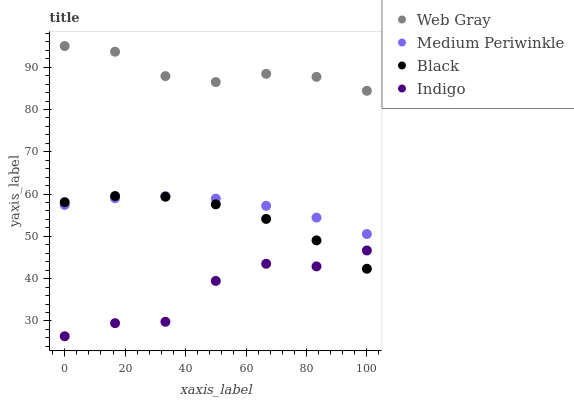Does Indigo have the minimum area under the curve?
Answer yes or no. Yes. Does Web Gray have the maximum area under the curve?
Answer yes or no. Yes. Does Medium Periwinkle have the minimum area under the curve?
Answer yes or no. No. Does Medium Periwinkle have the maximum area under the curve?
Answer yes or no. No. Is Medium Periwinkle the smoothest?
Answer yes or no. Yes. Is Indigo the roughest?
Answer yes or no. Yes. Is Web Gray the smoothest?
Answer yes or no. No. Is Web Gray the roughest?
Answer yes or no. No. Does Indigo have the lowest value?
Answer yes or no. Yes. Does Medium Periwinkle have the lowest value?
Answer yes or no. No. Does Web Gray have the highest value?
Answer yes or no. Yes. Does Medium Periwinkle have the highest value?
Answer yes or no. No. Is Indigo less than Medium Periwinkle?
Answer yes or no. Yes. Is Web Gray greater than Medium Periwinkle?
Answer yes or no. Yes. Does Medium Periwinkle intersect Black?
Answer yes or no. Yes. Is Medium Periwinkle less than Black?
Answer yes or no. No. Is Medium Periwinkle greater than Black?
Answer yes or no. No. Does Indigo intersect Medium Periwinkle?
Answer yes or no. No. 